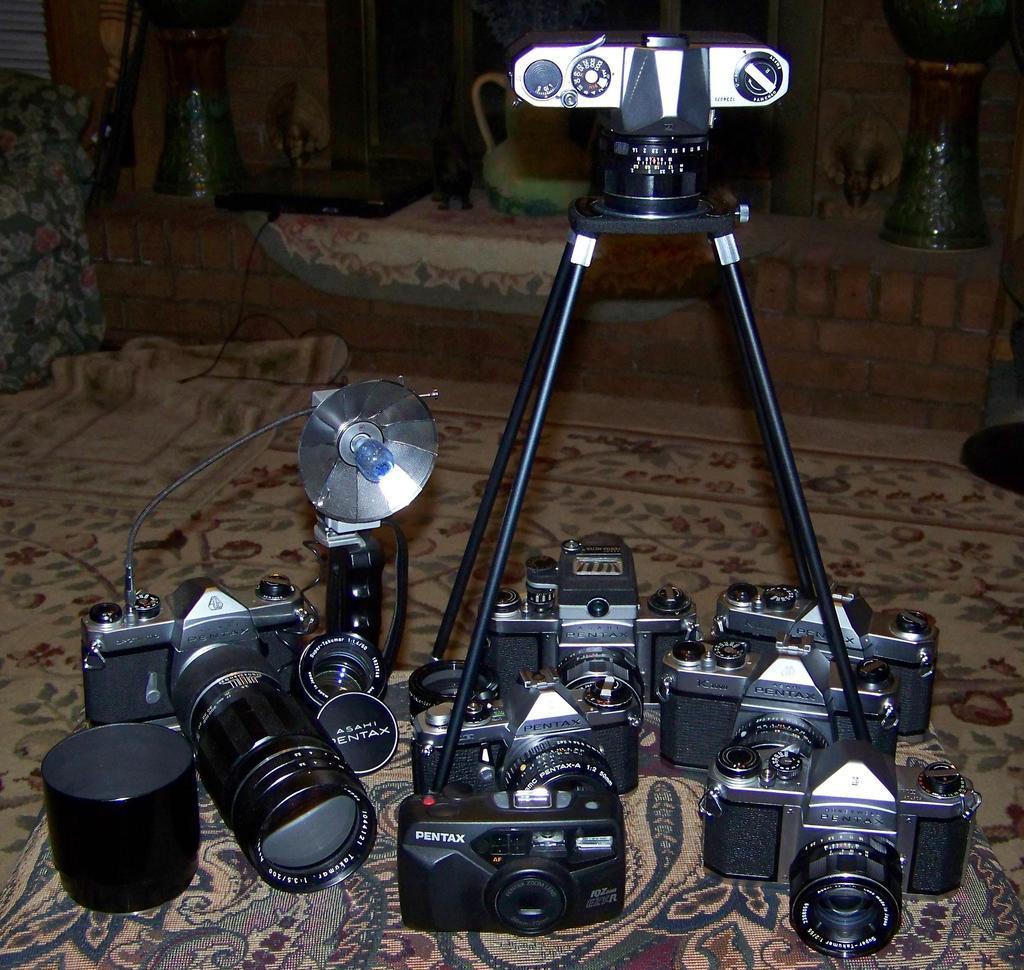In one or two sentences, can you explain what this image depicts? In this picture we can see many cameras, a flashlight and a camera stand on a carpet. In the background, we can see a lantern & a jug. 